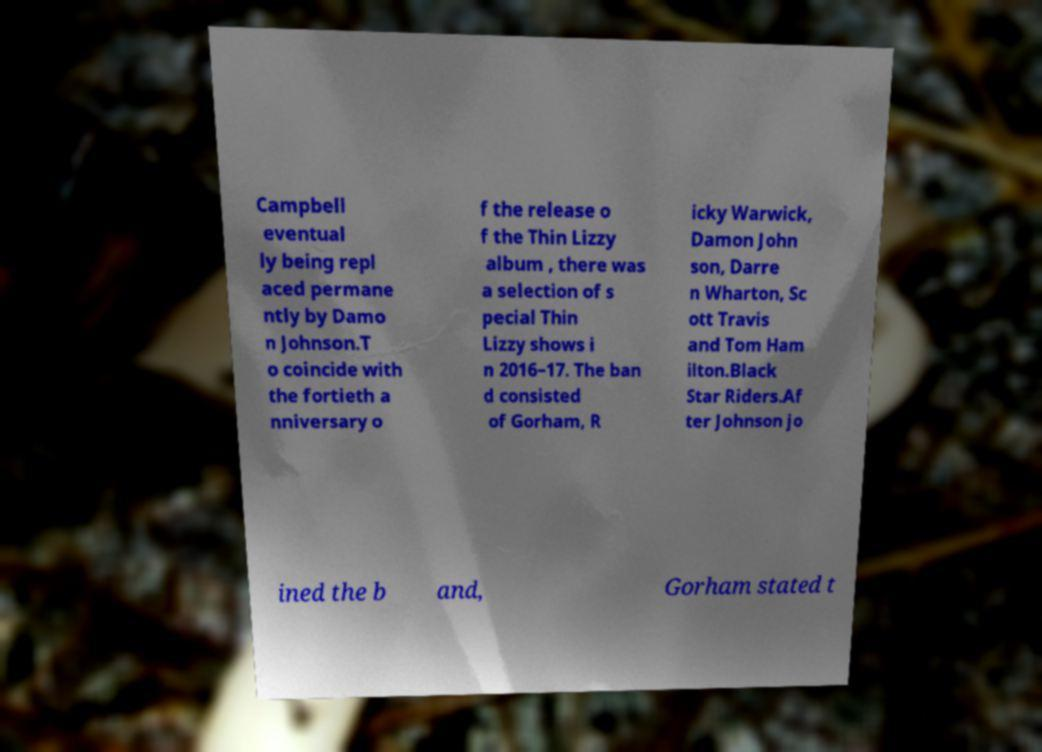Please read and relay the text visible in this image. What does it say? Campbell eventual ly being repl aced permane ntly by Damo n Johnson.T o coincide with the fortieth a nniversary o f the release o f the Thin Lizzy album , there was a selection of s pecial Thin Lizzy shows i n 2016–17. The ban d consisted of Gorham, R icky Warwick, Damon John son, Darre n Wharton, Sc ott Travis and Tom Ham ilton.Black Star Riders.Af ter Johnson jo ined the b and, Gorham stated t 